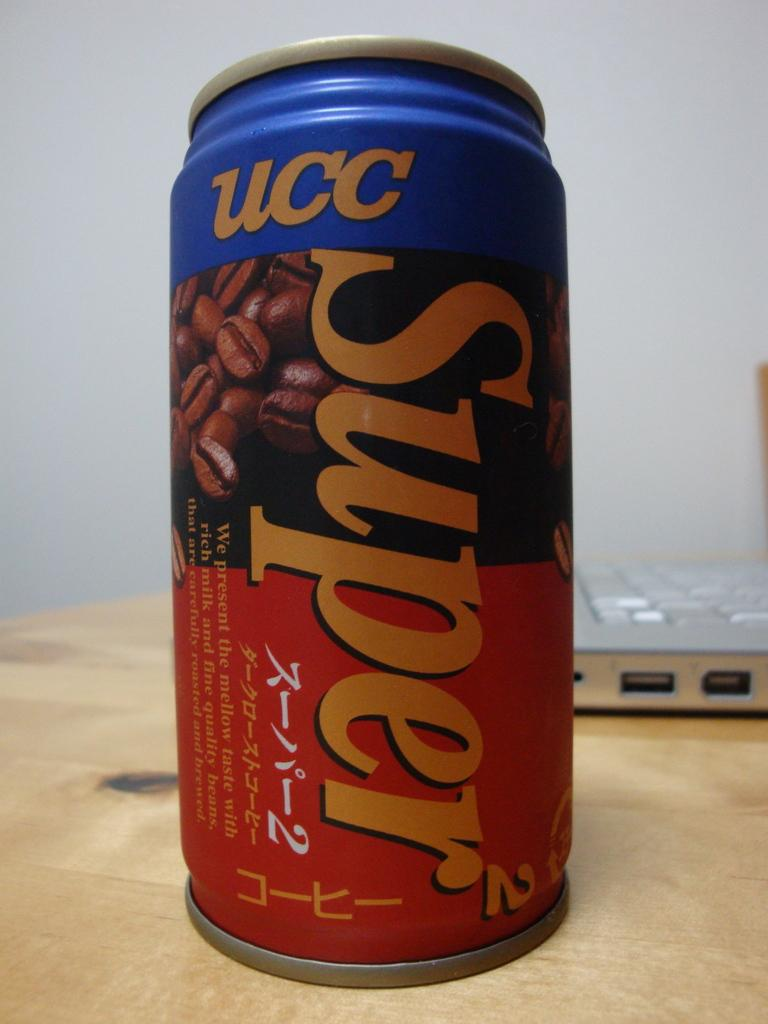Provide a one-sentence caption for the provided image. An aluminum can that reads UC super on the can. 